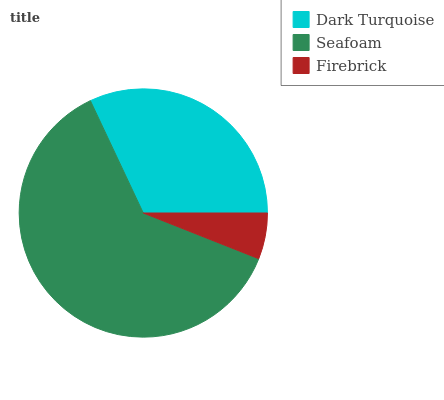Is Firebrick the minimum?
Answer yes or no. Yes. Is Seafoam the maximum?
Answer yes or no. Yes. Is Seafoam the minimum?
Answer yes or no. No. Is Firebrick the maximum?
Answer yes or no. No. Is Seafoam greater than Firebrick?
Answer yes or no. Yes. Is Firebrick less than Seafoam?
Answer yes or no. Yes. Is Firebrick greater than Seafoam?
Answer yes or no. No. Is Seafoam less than Firebrick?
Answer yes or no. No. Is Dark Turquoise the high median?
Answer yes or no. Yes. Is Dark Turquoise the low median?
Answer yes or no. Yes. Is Firebrick the high median?
Answer yes or no. No. Is Seafoam the low median?
Answer yes or no. No. 